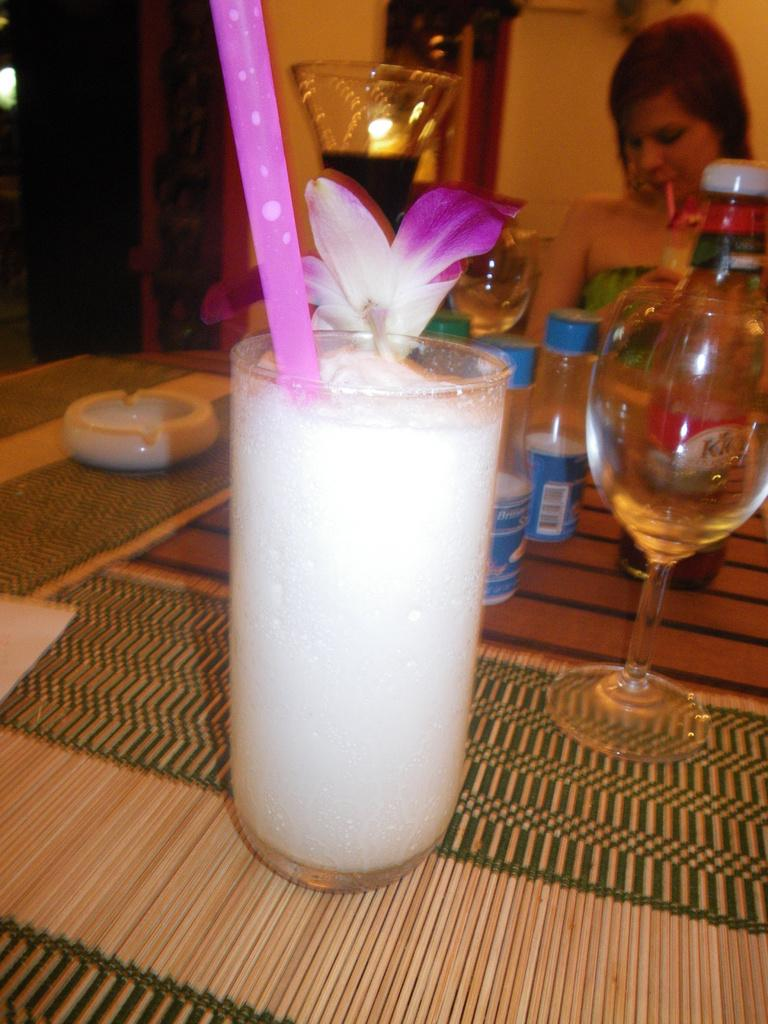What is present on the table in the image? There is a glass with juice, a straw, a flower, bottles, and other glasses on the table. What is the purpose of the straw in the glass? The straw is in the glass to help drink the juice. What is the decorative element on the table? There is a flower in the glass as a decorative element. What is used to protect the table from spills or heat? There are mats on the table to protect it. Can you describe the background of the image? There is a lady in the background of the image. How many snails can be seen crawling on the table in the image? There are no snails present on the table in the image. What is the best route to take to reach the credit card in the image? There is no credit card present in the image, so it is not possible to determine the best route to reach it. 